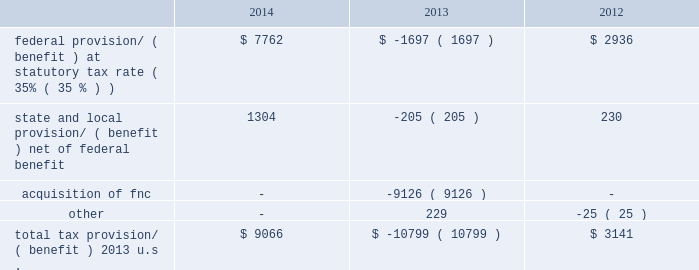Kimco realty corporation and subsidiaries notes to consolidated financial statements , continued the company 2019s investments in latin america are made through individual entities which are subject to local taxes .
The company assesses each entity to determine if deferred tax assets are more likely than not realizable .
This assessment primarily includes an analysis of cumulative earnings and the determination of future earnings to the extent necessary to fully realize the individual deferred tax asset .
Based on this analysis the company has determined that a full valuation allowance is required for entities which have a three-year cumulative book loss and for which future earnings are not readily determinable .
In addition , the company has determined that no valuation allowance is needed for entities that have three-years of cumulative book income and future earnings are anticipated to be sufficient to more likely than not realize their deferred tax assets .
At december 31 , 2014 , the company had total deferred tax assets of $ 9.5 million relating to its latin american investments with an aggregate valuation allowance of $ 9.3 million .
The company 2019s deferred tax assets in canada result principally from depreciation deducted under gaap that exceed capital cost allowances claimed under canadian tax rules .
The deferred tax asset will naturally reverse upon disposition as tax basis will be greater than the basis of the assets under generally accepted accounting principles .
As of december 31 , 2014 , the company determined that no valuation allowance was needed against a $ 65.5 million net deferred tax asset within krs .
The company based its determination on an analysis of both positive evidence and negative evidence using its judgment as to the relative weight of each .
The company believes , when evaluating krs 2019s deferred tax assets , special consideration should be given to the unique relationship between the company as a reit and krs as a taxable reit subsidiary .
This relationship exists primarily to protect the reit 2019s qualification under the code by permitting , within certain limits , the reit to engage in certain business activities in which the reit cannot directly participate .
As such , the reit controls which and when investments are held in , or distributed or sold from , krs .
This relationship distinguishes a reit and taxable reit subsidiary from an enterprise that operates as a single , consolidated corporate taxpayer .
The company will continue through this structure to operate certain business activities in krs .
The company 2019s analysis of krs 2019s ability to utilize its deferred tax assets includes an estimate of future projected income .
To determine future projected income , the company scheduled krs 2019s pre-tax book income and taxable income over a twenty year period taking into account its continuing operations ( 201ccore earnings 201d ) .
Core earnings consist of estimated net operating income for properties currently in service and generating rental income .
Major lease turnover is not expected in these properties as these properties were generally constructed and leased within the past seven years .
The company can employ strategies to realize krs 2019s deferred tax assets including transferring its property management business or selling certain built-in gain assets .
The company 2019s projection of krs 2019s future taxable income over twenty years , utilizing the assumptions above with respect to core earnings , net of related expenses , generates sufficient taxable income to absorb a reversal of the company 2019s deductible temporary differences , including net operating loss carryovers .
Based on this analysis , the company concluded it is more likely than not that krs 2019s net deferred tax asset of $ 65.5 million ( excluding net deferred tax assets of fnc discussed above ) will be realized and therefore , no valuation allowance is needed at december 31 , 2014 .
If future income projections do not occur as forecasted or the company incurs additional impairment losses in excess of the amount core earnings can absorb , the company will reconsider the need for a valuation allowance .
Provision/ ( benefit ) differ from the amounts computed by applying the statutory federal income tax rate to taxable income before income taxes as follows ( in thousands ) : .

What was the change in the federal provision/ ( benefit ) from 2013 to 2014 in millions? 
Computations: (7762 - -1697)
Answer: 9459.0. 